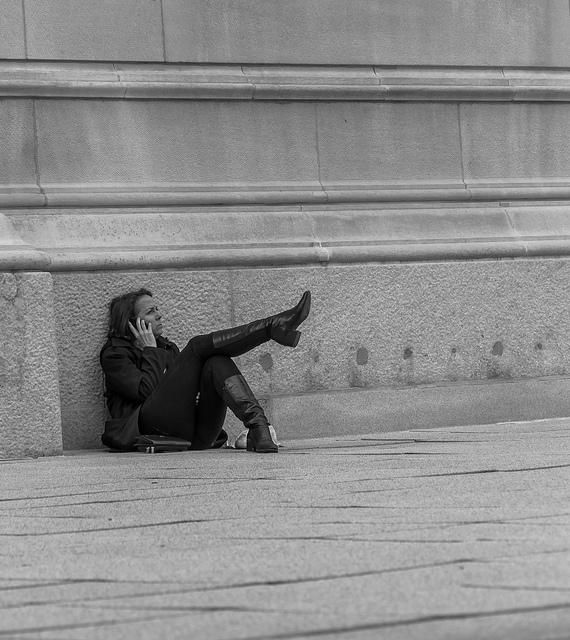What other people are known to sit in locations like this in this position? Please explain your reasoning. pan handlers. Panhandlers beg for money on streets. 